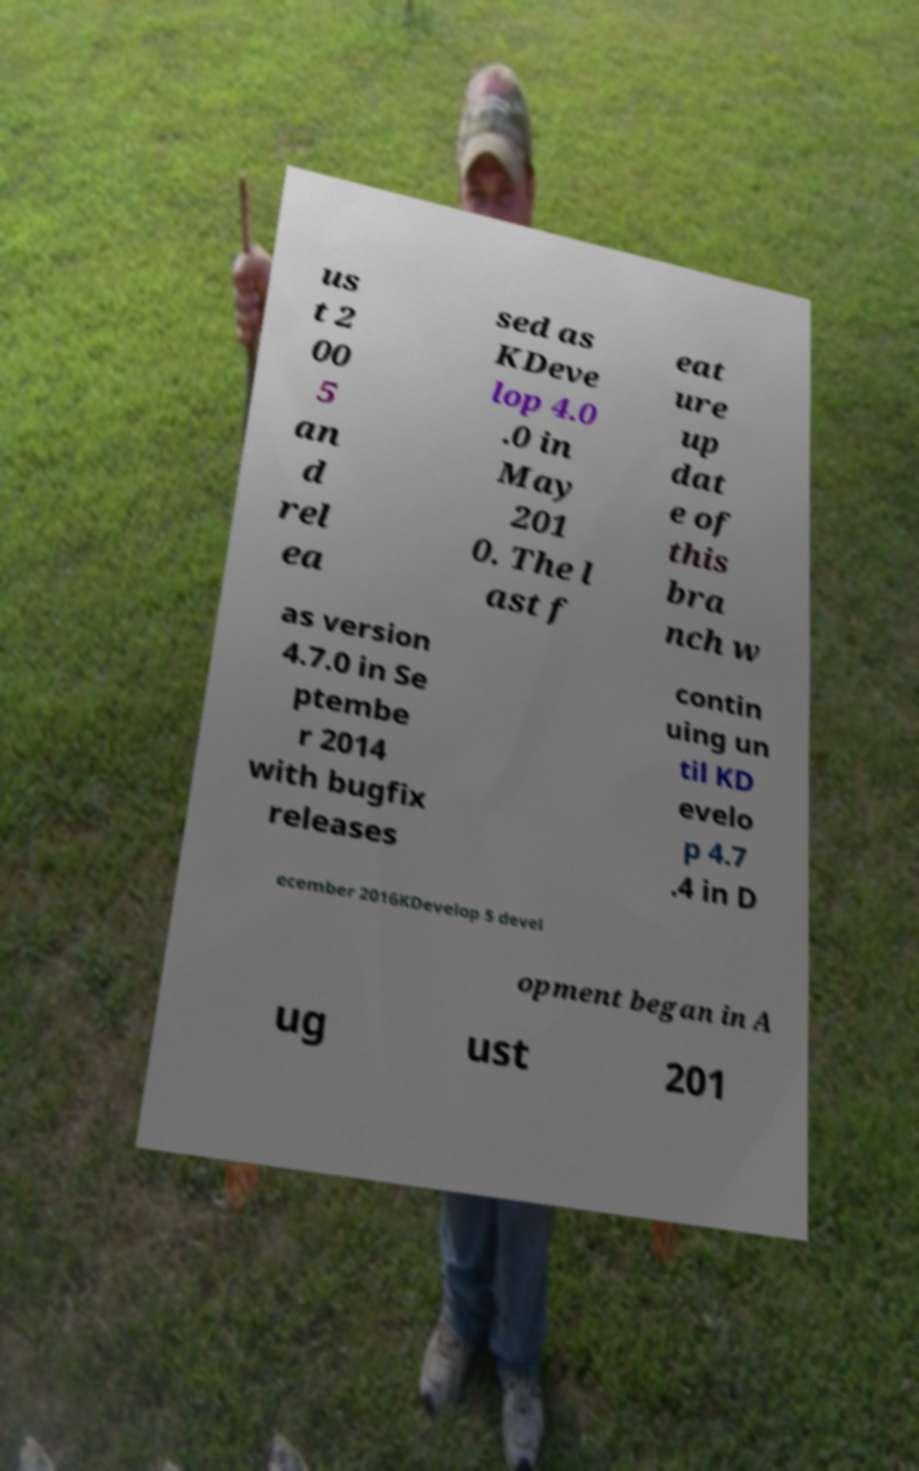Please identify and transcribe the text found in this image. us t 2 00 5 an d rel ea sed as KDeve lop 4.0 .0 in May 201 0. The l ast f eat ure up dat e of this bra nch w as version 4.7.0 in Se ptembe r 2014 with bugfix releases contin uing un til KD evelo p 4.7 .4 in D ecember 2016KDevelop 5 devel opment began in A ug ust 201 